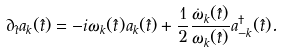<formula> <loc_0><loc_0><loc_500><loc_500>\partial _ { \hat { t } } a _ { k } ( \hat { t } ) = - i \omega _ { k } ( \hat { t } ) a _ { k } ( \hat { t } ) + \frac { 1 } { 2 } \frac { \dot { \omega } _ { k } ( \hat { t } ) } { \omega _ { k } ( \hat { t } ) } a _ { - k } ^ { \dag } ( \hat { t } ) .</formula> 